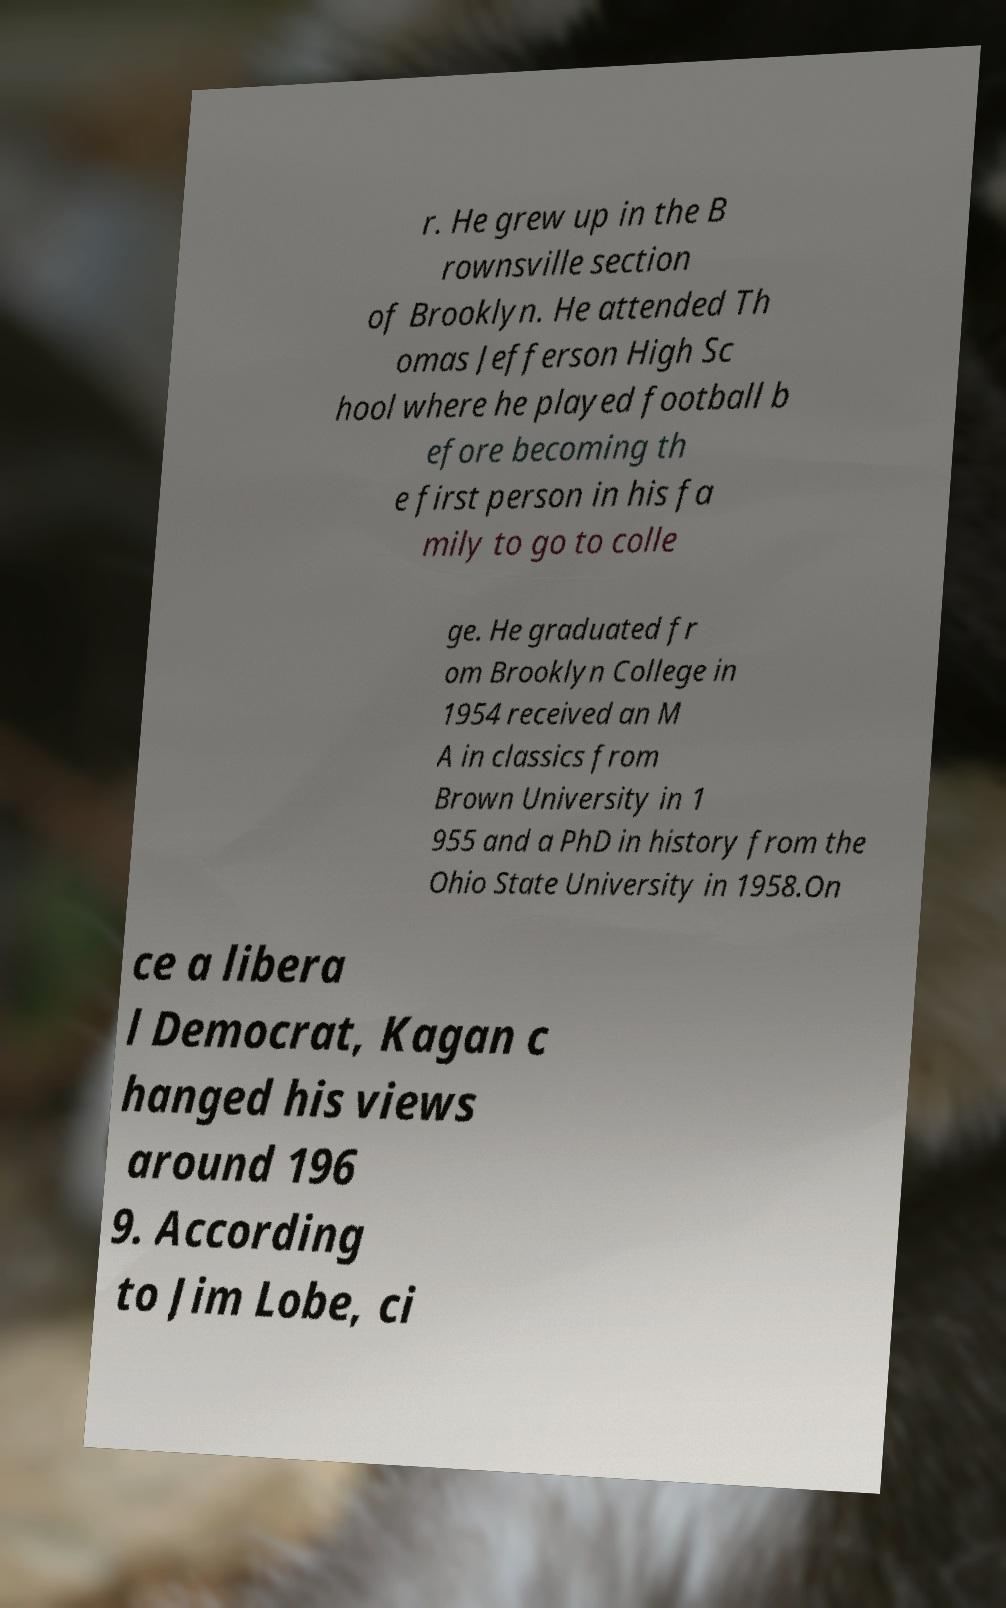Please read and relay the text visible in this image. What does it say? r. He grew up in the B rownsville section of Brooklyn. He attended Th omas Jefferson High Sc hool where he played football b efore becoming th e first person in his fa mily to go to colle ge. He graduated fr om Brooklyn College in 1954 received an M A in classics from Brown University in 1 955 and a PhD in history from the Ohio State University in 1958.On ce a libera l Democrat, Kagan c hanged his views around 196 9. According to Jim Lobe, ci 